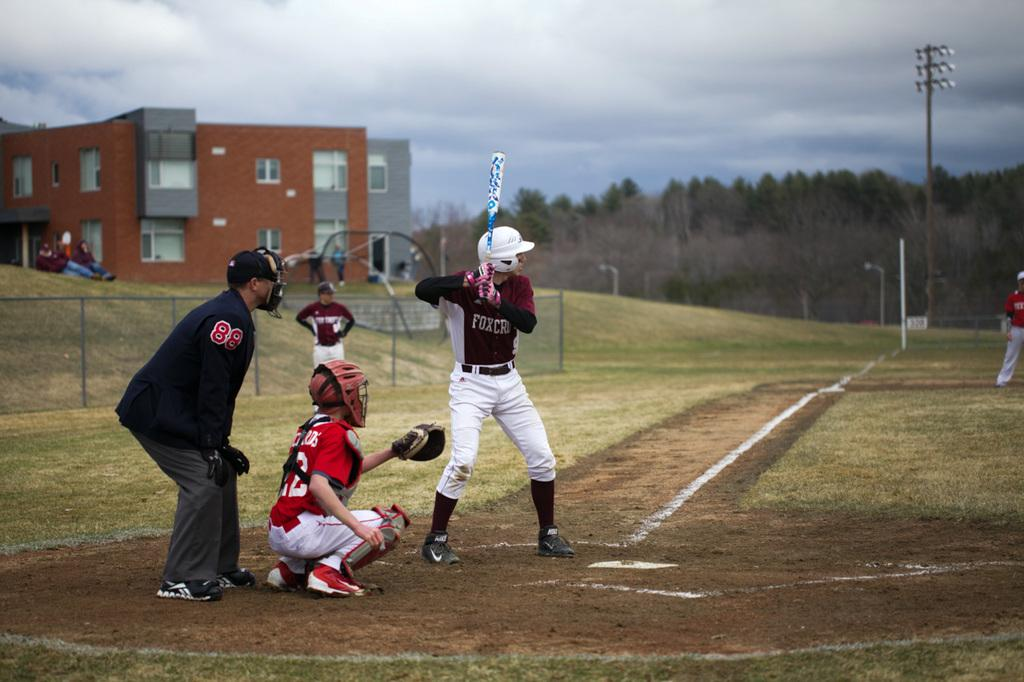<image>
Present a compact description of the photo's key features. Juvenile baseball player up to bat wearing a FoxCru jersey. 